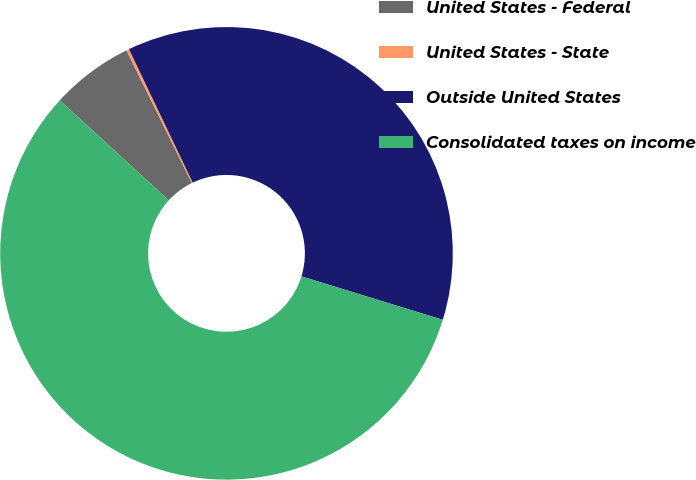Convert chart. <chart><loc_0><loc_0><loc_500><loc_500><pie_chart><fcel>United States - Federal<fcel>United States - State<fcel>Outside United States<fcel>Consolidated taxes on income<nl><fcel>5.89%<fcel>0.2%<fcel>36.83%<fcel>57.07%<nl></chart> 